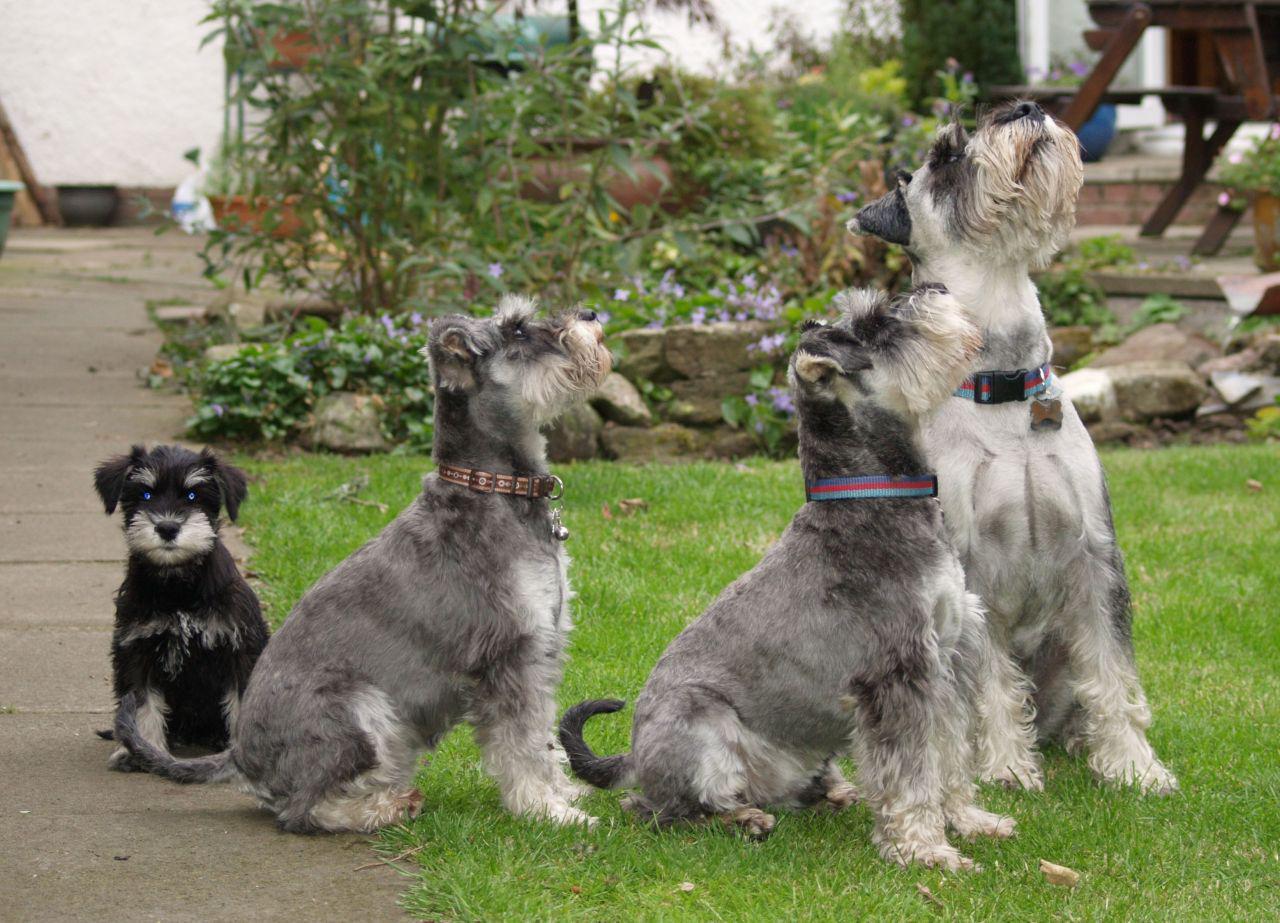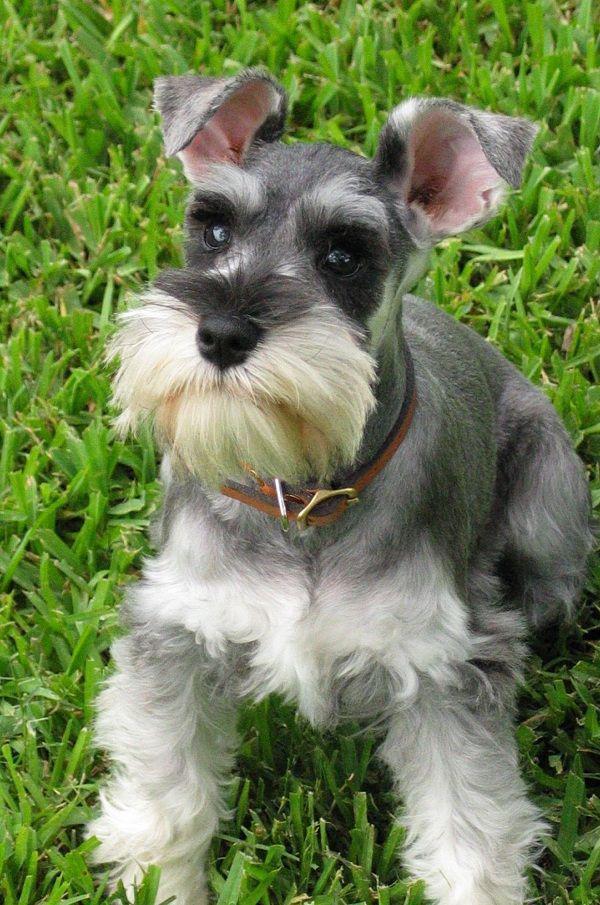The first image is the image on the left, the second image is the image on the right. Analyze the images presented: Is the assertion "At least one of the dogs is sitting on the cement." valid? Answer yes or no. Yes. 